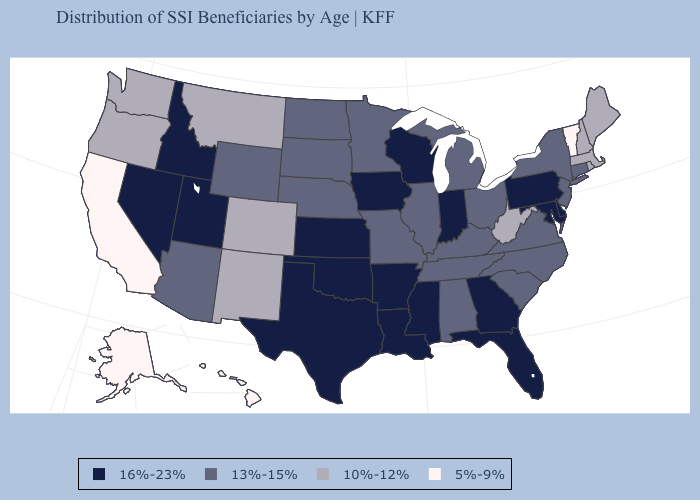Which states have the lowest value in the USA?
Keep it brief. Alaska, California, Hawaii, Vermont. What is the value of New Hampshire?
Be succinct. 10%-12%. What is the value of Illinois?
Be succinct. 13%-15%. Does Louisiana have a lower value than Alabama?
Quick response, please. No. Name the states that have a value in the range 10%-12%?
Give a very brief answer. Colorado, Maine, Massachusetts, Montana, New Hampshire, New Mexico, Oregon, Rhode Island, Washington, West Virginia. Does California have the lowest value in the West?
Short answer required. Yes. What is the highest value in states that border Iowa?
Write a very short answer. 16%-23%. Does Nebraska have the highest value in the MidWest?
Quick response, please. No. How many symbols are there in the legend?
Write a very short answer. 4. Name the states that have a value in the range 5%-9%?
Quick response, please. Alaska, California, Hawaii, Vermont. Which states have the highest value in the USA?
Quick response, please. Arkansas, Delaware, Florida, Georgia, Idaho, Indiana, Iowa, Kansas, Louisiana, Maryland, Mississippi, Nevada, Oklahoma, Pennsylvania, Texas, Utah, Wisconsin. What is the value of North Carolina?
Short answer required. 13%-15%. Does Indiana have the lowest value in the MidWest?
Quick response, please. No. Does the first symbol in the legend represent the smallest category?
Concise answer only. No. How many symbols are there in the legend?
Write a very short answer. 4. 